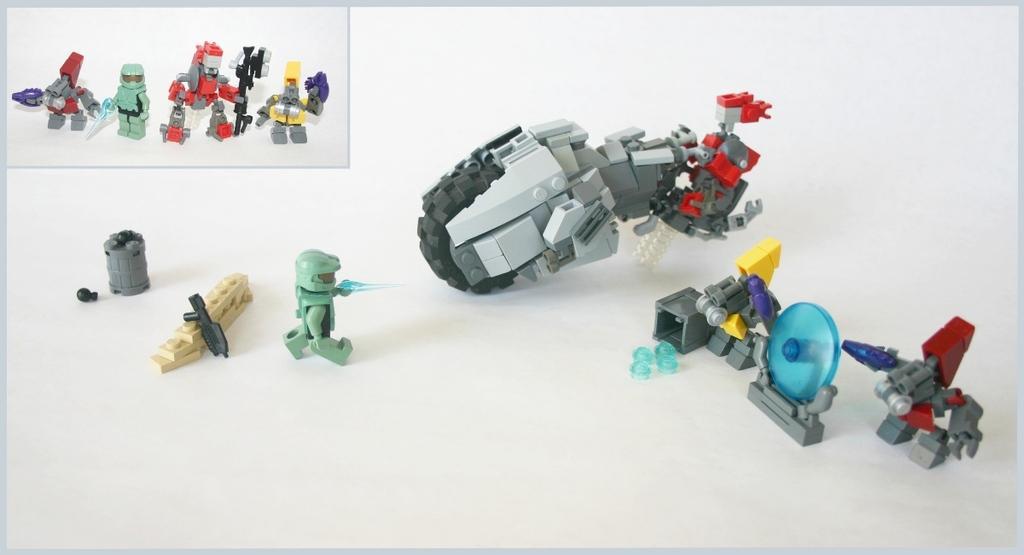In one or two sentences, can you explain what this image depicts? In this image, we can see some toys on white background. 